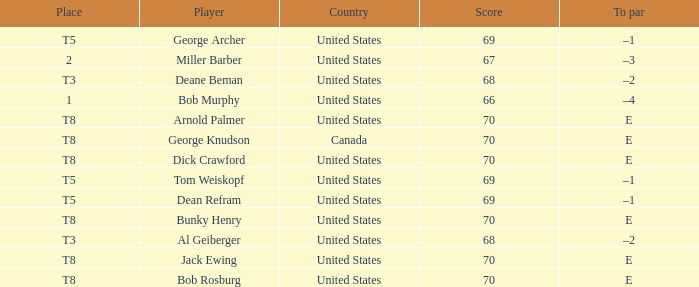When Bunky Henry of the United States scored higher than 68 and his To par was e, what was his place? T8. 